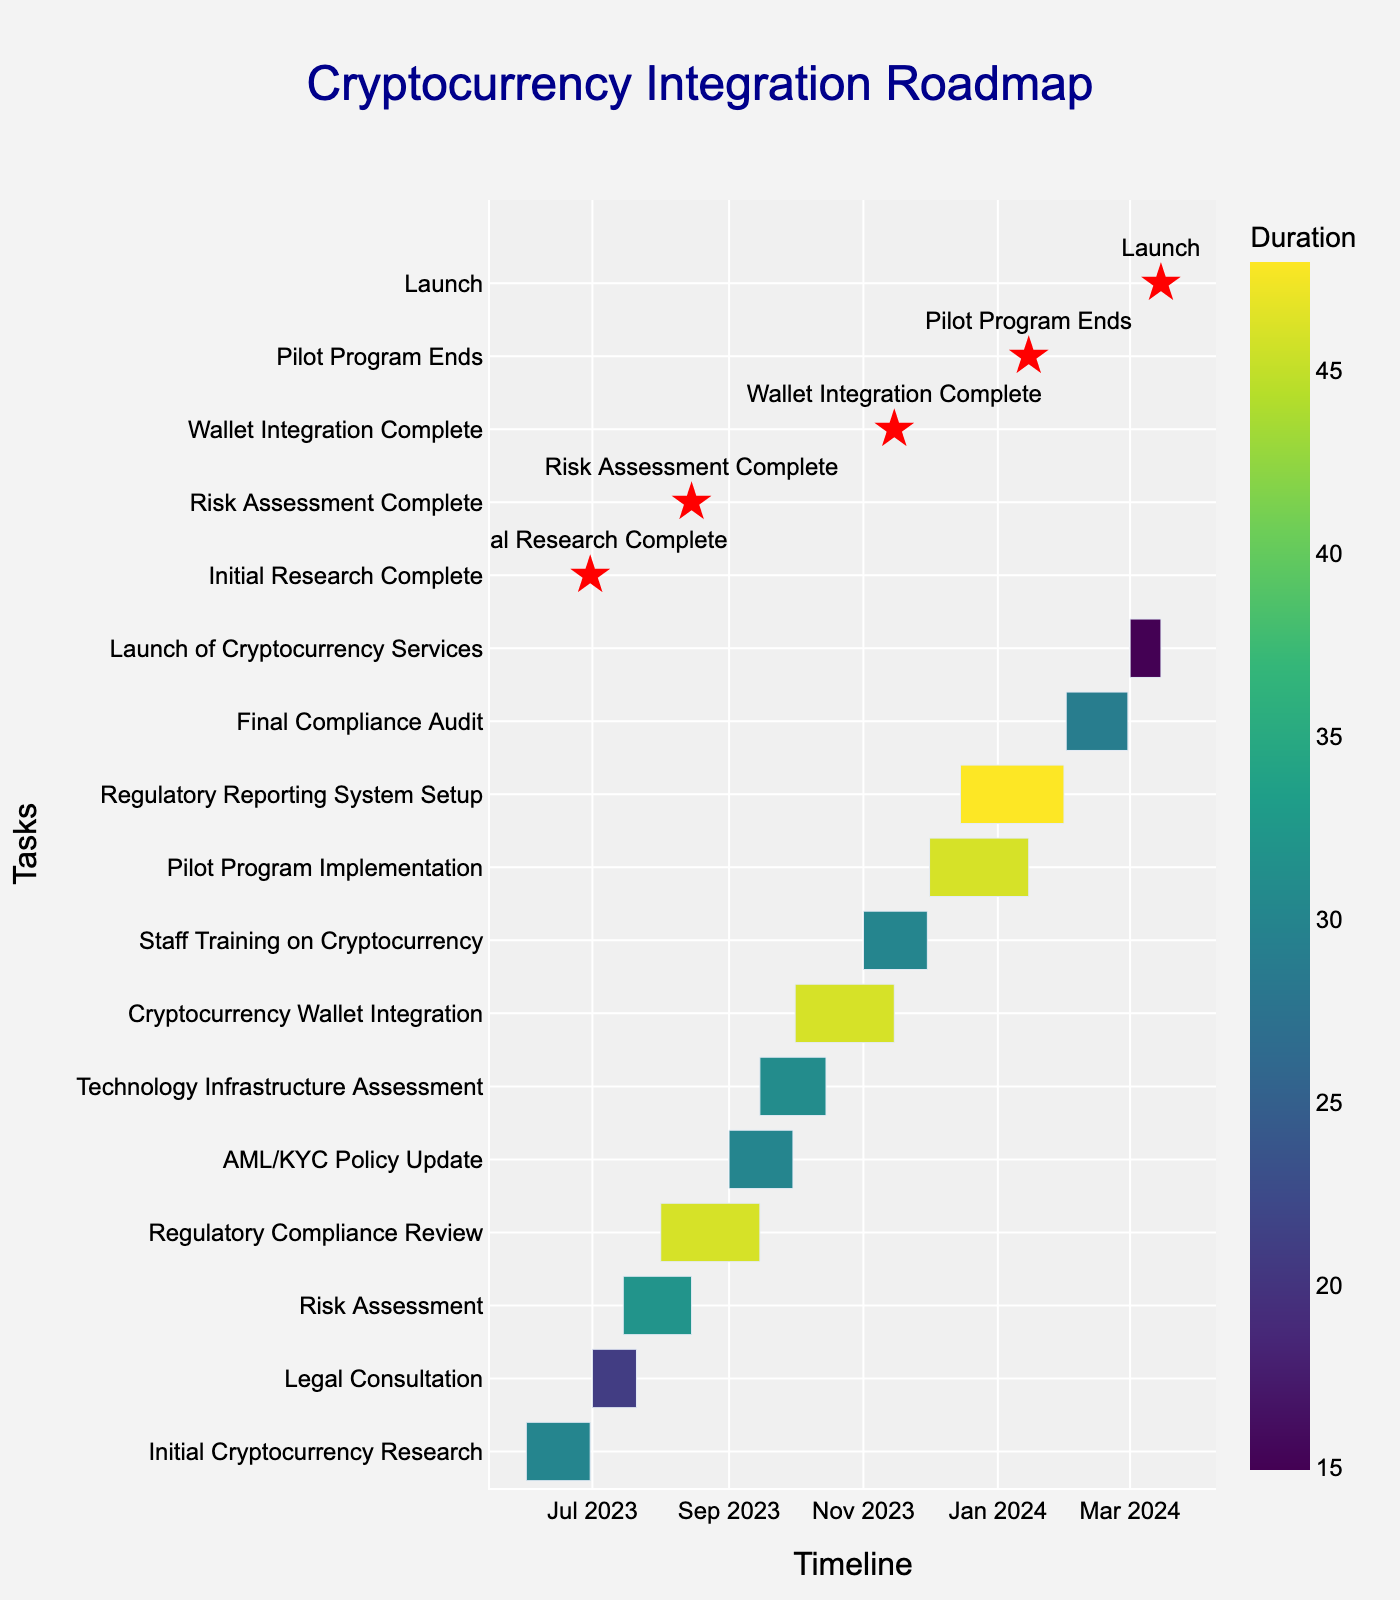What is the title of the Gantt chart? The title of the Gantt chart is typically found at the top of the chart. In this case, it is stated as "Cryptocurrency Integration Roadmap."
Answer: Cryptocurrency Integration Roadmap Which task has the longest duration? To identify the task with the longest duration, check the Duration column for the largest number. "Regulatory Reporting System Setup" has a duration of 48 days, which is the longest.
Answer: Regulatory Reporting System Setup When does the "Pilot Program Implementation" task end? The end date of the "Pilot Program Implementation" task can be found by looking at the End Date column for that task. It ends on January 15, 2024.
Answer: January 15, 2024 How many tasks are scheduled to be completed by the end of November 2023? Check the End Date column to see which tasks end on or before November 30, 2023. The tasks that end by then are "Initial Cryptocurrency Research," "Legal Consultation," "Risk Assessment," "Regulatory Compliance Review," "AML/KYC Policy Update," "Technology Infrastructure Assessment," "Cryptocurrency Wallet Integration," and "Staff Training on Cryptocurrency." So, there are 8 tasks.
Answer: 8 Which two tasks overlap between August 1, 2023, and August 15, 2023? To find overlapping tasks, check the Start and End Dates of each task. "Regulatory Compliance Review" (August 1, 2023 - September 15, 2023) and "Risk Assessment" (July 15, 2023 - August 15, 2023) overlap during this period.
Answer: Regulatory Compliance Review, Risk Assessment How many total days does the "Final Compliance Audit" task take? The duration of "Final Compliance Audit" can be found in the Duration column. It takes 29 days.
Answer: 29 Which task starts immediately after "Cryptocurrency Wallet Integration" ends? "Cryptocurrency Wallet Integration" ends on November 15, 2023. The next task starting immediately on November 16, 2023, is "Staff Training on Cryptocurrency," which begins on November 16, 2023.
Answer: Staff Training on Cryptocurrency How long is the gap between the end of "Staff Training on Cryptocurrency" and the start of "Pilot Program Implementation"? "Staff Training on Cryptocurrency" ends on November 30, 2023, and "Pilot Program Implementation" starts on December 1, 2023. Therefore, the gap is just 1 day.
Answer: 1 day 